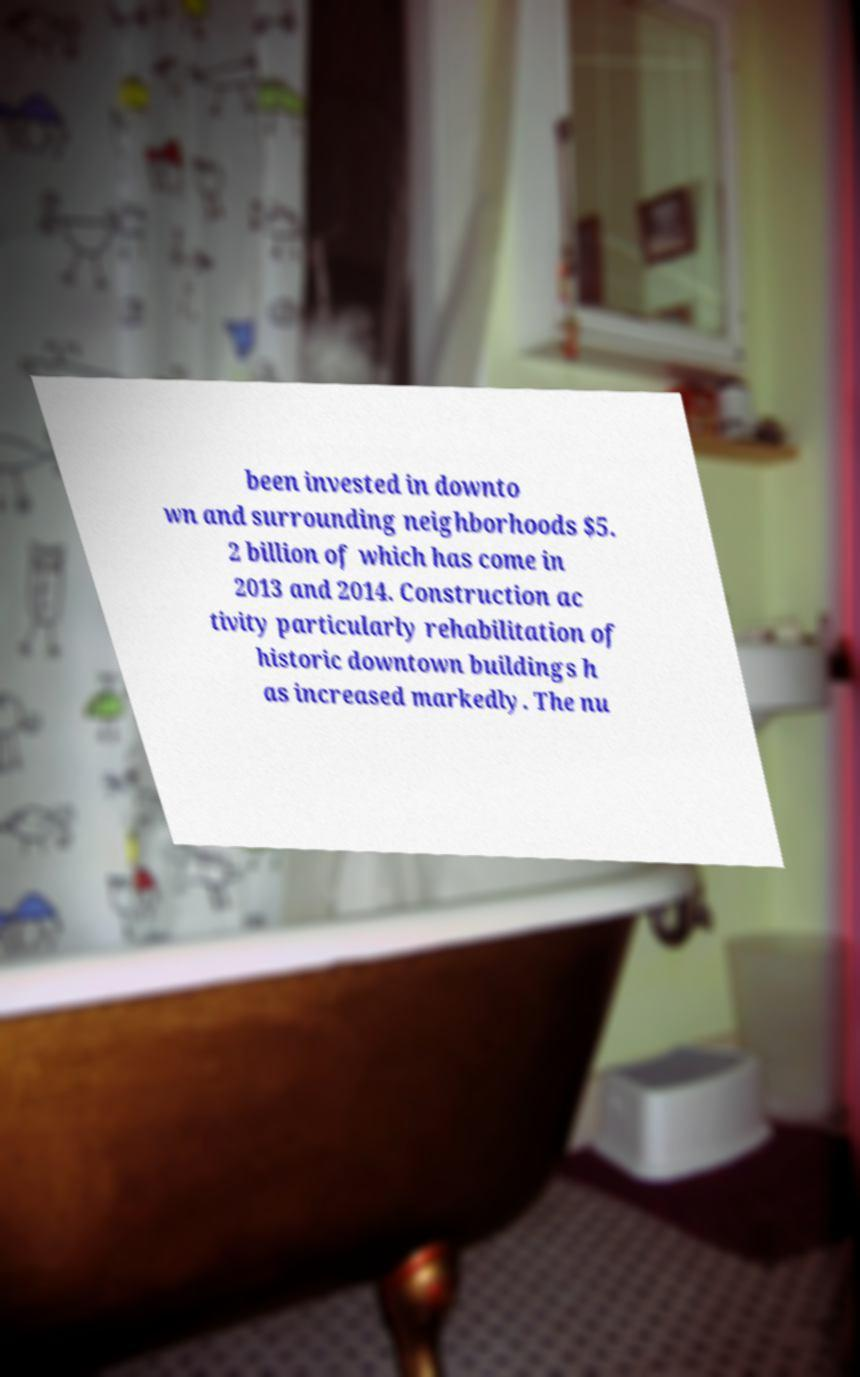There's text embedded in this image that I need extracted. Can you transcribe it verbatim? been invested in downto wn and surrounding neighborhoods $5. 2 billion of which has come in 2013 and 2014. Construction ac tivity particularly rehabilitation of historic downtown buildings h as increased markedly. The nu 